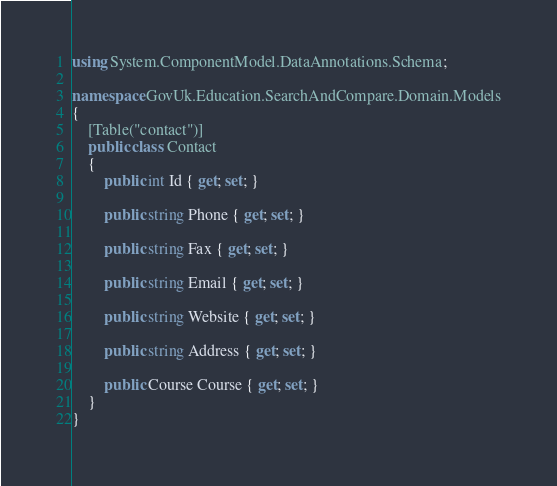<code> <loc_0><loc_0><loc_500><loc_500><_C#_>using System.ComponentModel.DataAnnotations.Schema;

namespace GovUk.Education.SearchAndCompare.Domain.Models
{
    [Table("contact")]
    public class Contact
    {
        public int Id { get; set; }

        public string Phone { get; set; }

        public string Fax { get; set; }

        public string Email { get; set; }

        public string Website { get; set; }

        public string Address { get; set; }

        public Course Course { get; set; }
    }
}</code> 